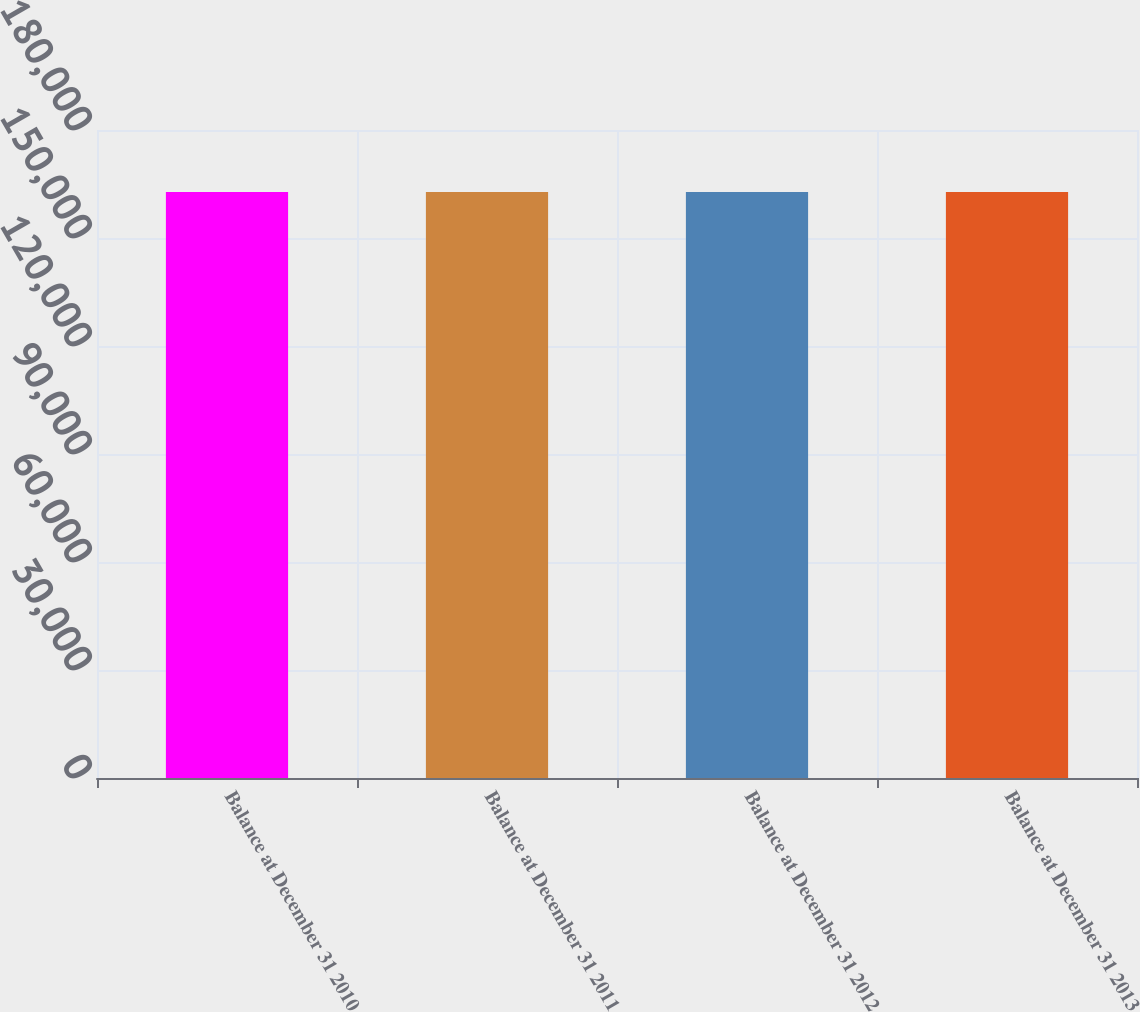Convert chart. <chart><loc_0><loc_0><loc_500><loc_500><bar_chart><fcel>Balance at December 31 2010<fcel>Balance at December 31 2011<fcel>Balance at December 31 2012<fcel>Balance at December 31 2013<nl><fcel>162776<fcel>162776<fcel>162776<fcel>162776<nl></chart> 